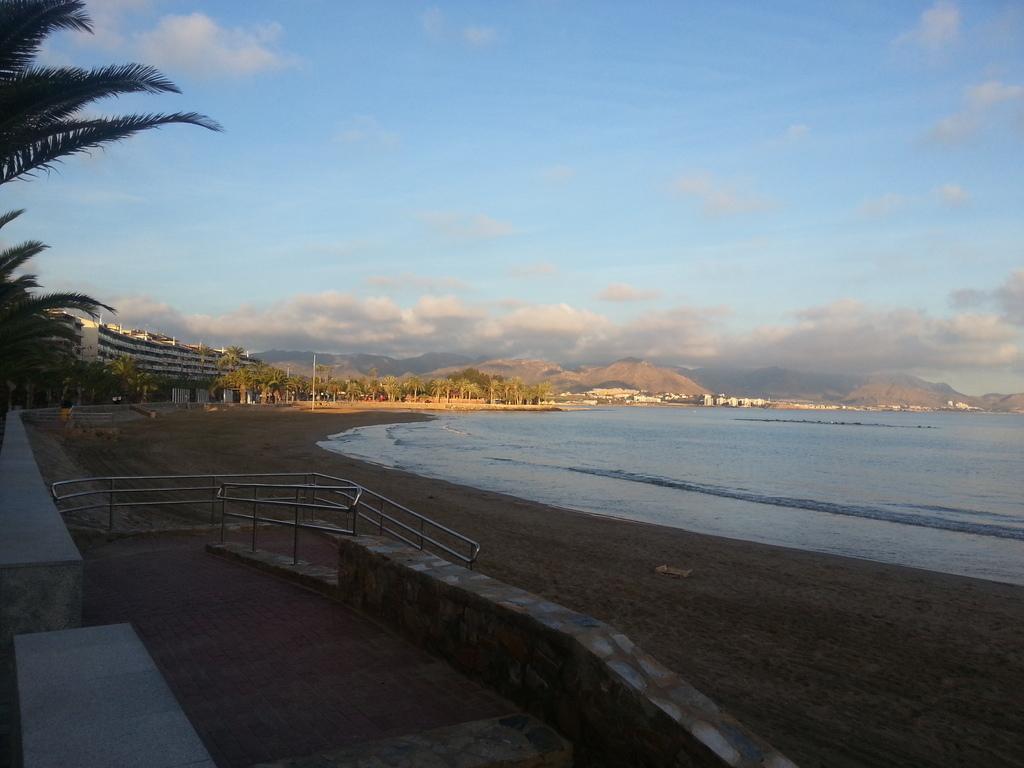How would you summarize this image in a sentence or two? In this image, we can see walkways, rod railings, wall, ground and water. Background we can see trees, poles, buildings, hills and cloudy sky. 